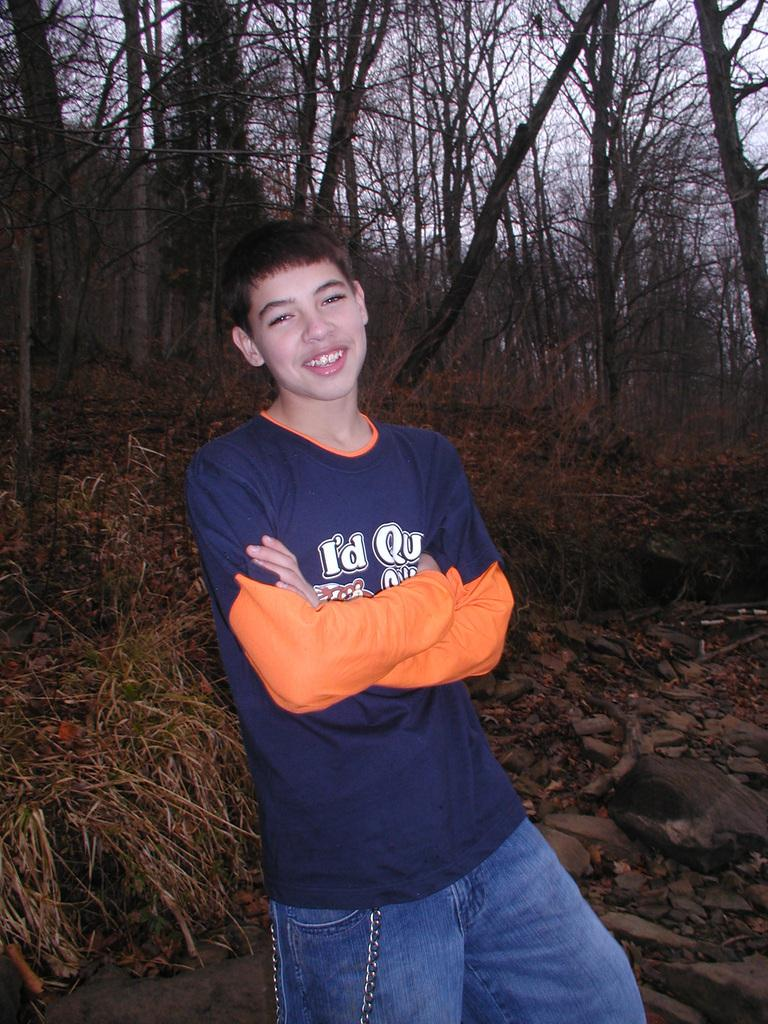<image>
Share a concise interpretation of the image provided. a person with has a blue shirt with the word I'd on it 